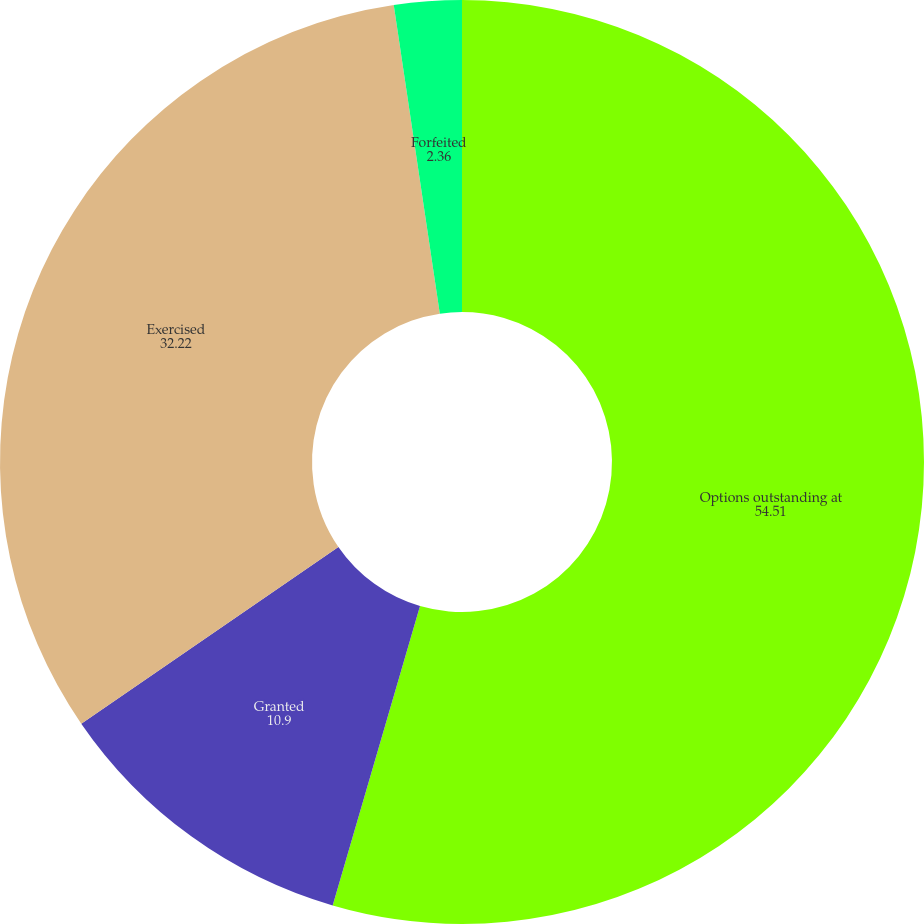Convert chart. <chart><loc_0><loc_0><loc_500><loc_500><pie_chart><fcel>Options outstanding at<fcel>Granted<fcel>Exercised<fcel>Forfeited<nl><fcel>54.51%<fcel>10.9%<fcel>32.22%<fcel>2.36%<nl></chart> 